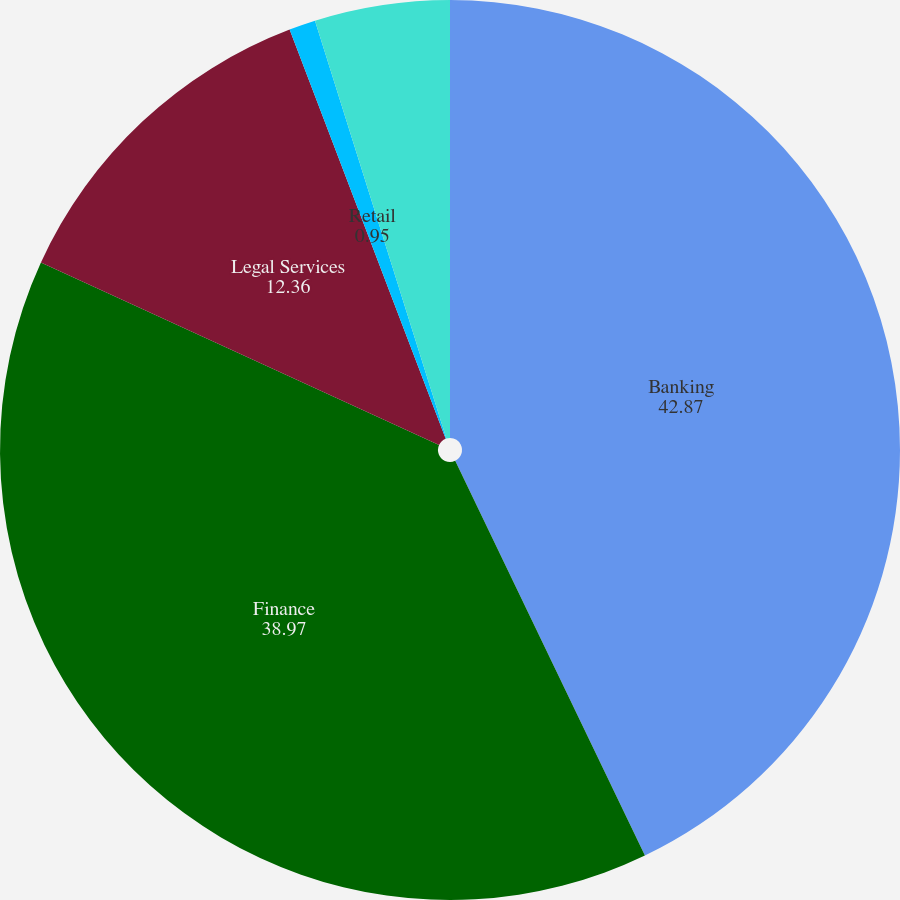Convert chart to OTSL. <chart><loc_0><loc_0><loc_500><loc_500><pie_chart><fcel>Banking<fcel>Finance<fcel>Legal Services<fcel>Retail<fcel>Others<nl><fcel>42.87%<fcel>38.97%<fcel>12.36%<fcel>0.95%<fcel>4.85%<nl></chart> 